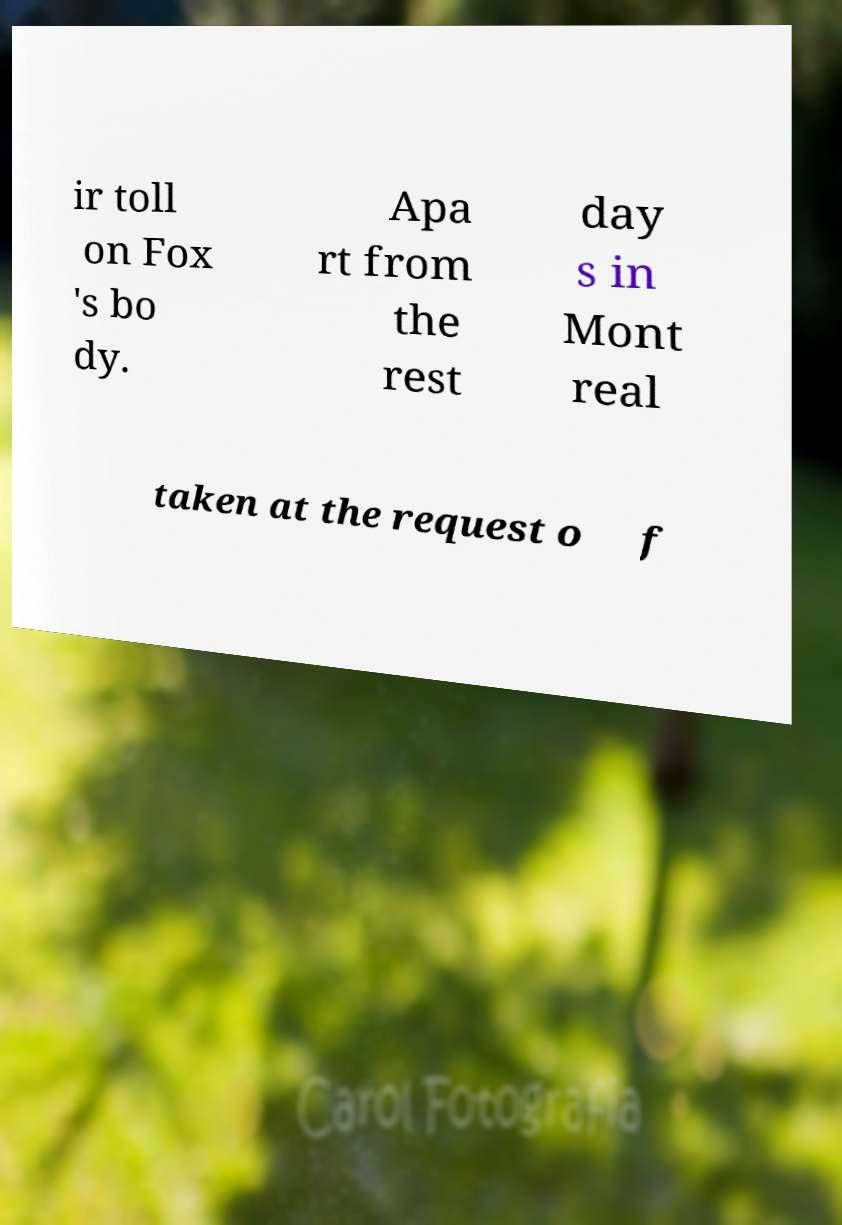Can you read and provide the text displayed in the image?This photo seems to have some interesting text. Can you extract and type it out for me? ir toll on Fox 's bo dy. Apa rt from the rest day s in Mont real taken at the request o f 